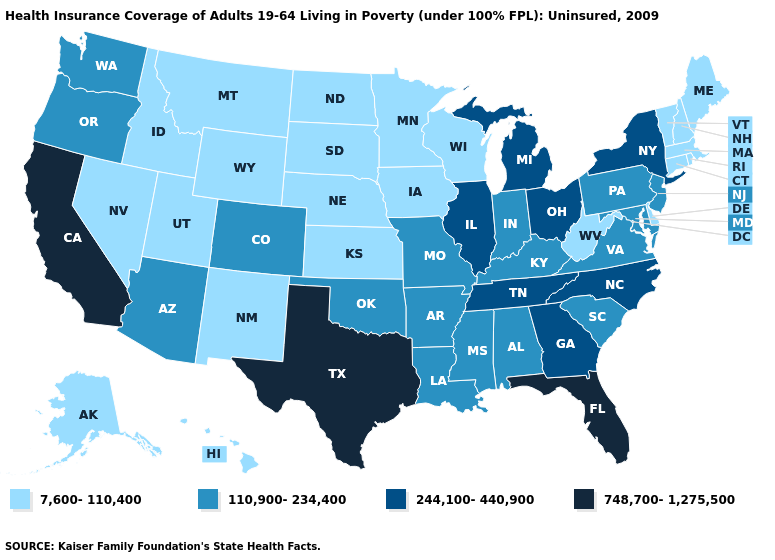Among the states that border Missouri , which have the highest value?
Write a very short answer. Illinois, Tennessee. Does North Dakota have a lower value than Connecticut?
Keep it brief. No. Among the states that border Tennessee , does Virginia have the lowest value?
Concise answer only. Yes. Does Alaska have the lowest value in the USA?
Short answer required. Yes. What is the value of New Mexico?
Answer briefly. 7,600-110,400. Which states have the lowest value in the USA?
Quick response, please. Alaska, Connecticut, Delaware, Hawaii, Idaho, Iowa, Kansas, Maine, Massachusetts, Minnesota, Montana, Nebraska, Nevada, New Hampshire, New Mexico, North Dakota, Rhode Island, South Dakota, Utah, Vermont, West Virginia, Wisconsin, Wyoming. Does Alabama have the lowest value in the USA?
Give a very brief answer. No. Name the states that have a value in the range 748,700-1,275,500?
Concise answer only. California, Florida, Texas. What is the value of Texas?
Answer briefly. 748,700-1,275,500. Name the states that have a value in the range 110,900-234,400?
Give a very brief answer. Alabama, Arizona, Arkansas, Colorado, Indiana, Kentucky, Louisiana, Maryland, Mississippi, Missouri, New Jersey, Oklahoma, Oregon, Pennsylvania, South Carolina, Virginia, Washington. Which states have the lowest value in the USA?
Keep it brief. Alaska, Connecticut, Delaware, Hawaii, Idaho, Iowa, Kansas, Maine, Massachusetts, Minnesota, Montana, Nebraska, Nevada, New Hampshire, New Mexico, North Dakota, Rhode Island, South Dakota, Utah, Vermont, West Virginia, Wisconsin, Wyoming. What is the lowest value in the Northeast?
Be succinct. 7,600-110,400. What is the value of Arizona?
Quick response, please. 110,900-234,400. Does North Carolina have a higher value than Florida?
Write a very short answer. No. Name the states that have a value in the range 748,700-1,275,500?
Answer briefly. California, Florida, Texas. 